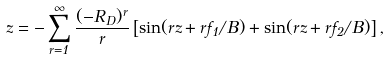Convert formula to latex. <formula><loc_0><loc_0><loc_500><loc_500>z = - \sum _ { r = 1 } ^ { \infty } \frac { ( - R _ { D } ) ^ { r } } { r } \left [ \sin ( r z + r f _ { 1 } / B ) + \sin ( r z + r f _ { 2 } / B ) \right ] ,</formula> 